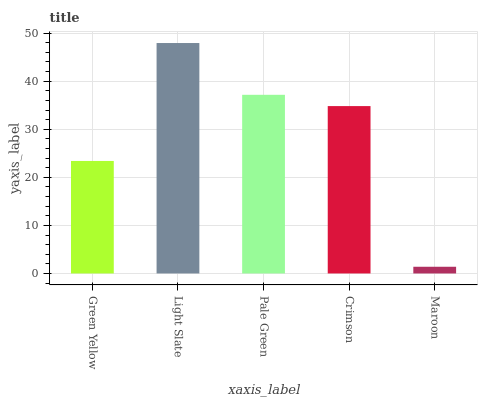Is Maroon the minimum?
Answer yes or no. Yes. Is Light Slate the maximum?
Answer yes or no. Yes. Is Pale Green the minimum?
Answer yes or no. No. Is Pale Green the maximum?
Answer yes or no. No. Is Light Slate greater than Pale Green?
Answer yes or no. Yes. Is Pale Green less than Light Slate?
Answer yes or no. Yes. Is Pale Green greater than Light Slate?
Answer yes or no. No. Is Light Slate less than Pale Green?
Answer yes or no. No. Is Crimson the high median?
Answer yes or no. Yes. Is Crimson the low median?
Answer yes or no. Yes. Is Maroon the high median?
Answer yes or no. No. Is Pale Green the low median?
Answer yes or no. No. 